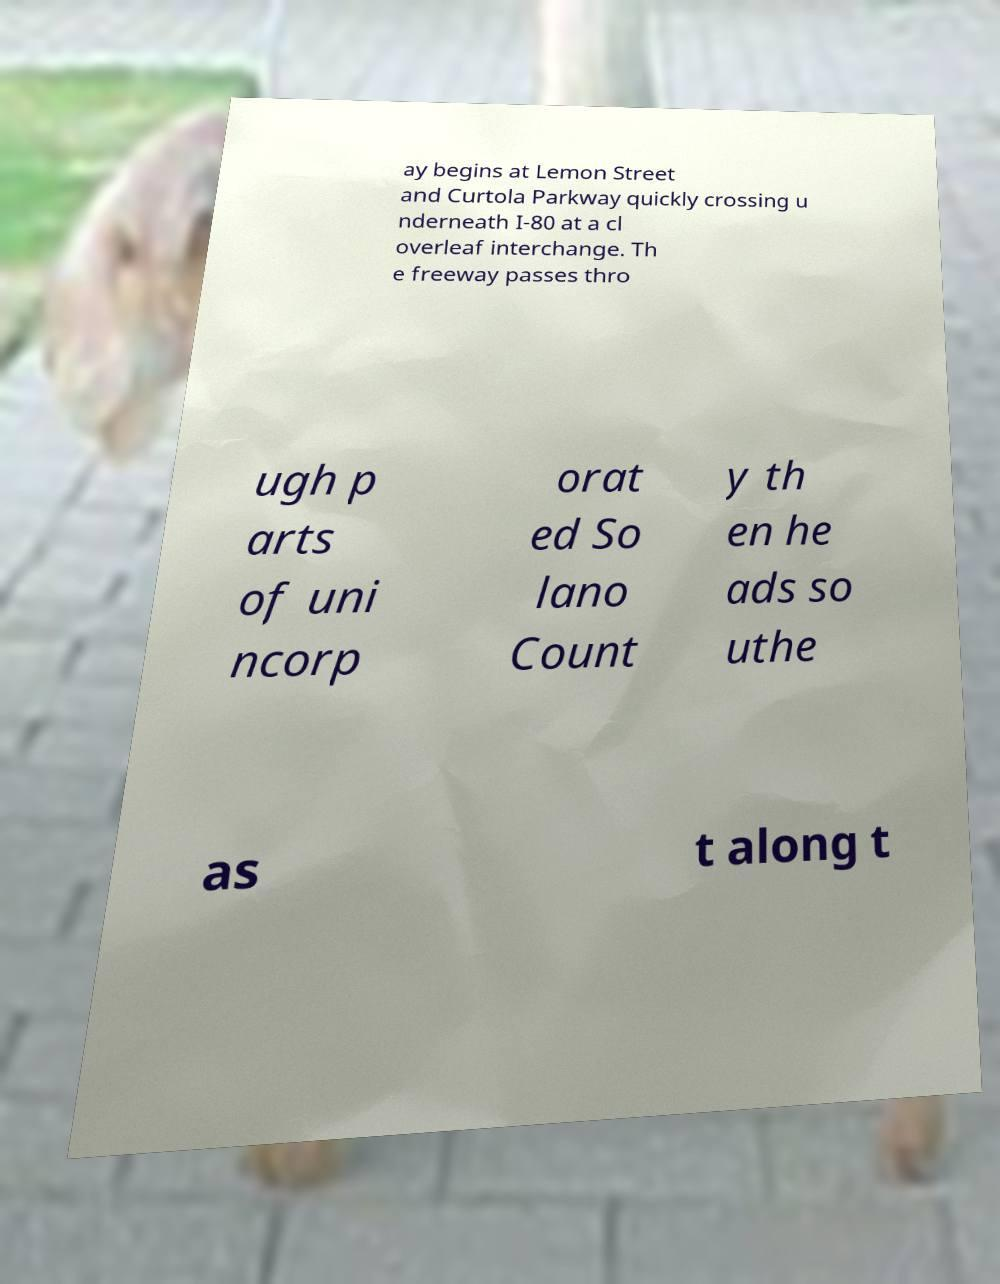I need the written content from this picture converted into text. Can you do that? ay begins at Lemon Street and Curtola Parkway quickly crossing u nderneath I-80 at a cl overleaf interchange. Th e freeway passes thro ugh p arts of uni ncorp orat ed So lano Count y th en he ads so uthe as t along t 